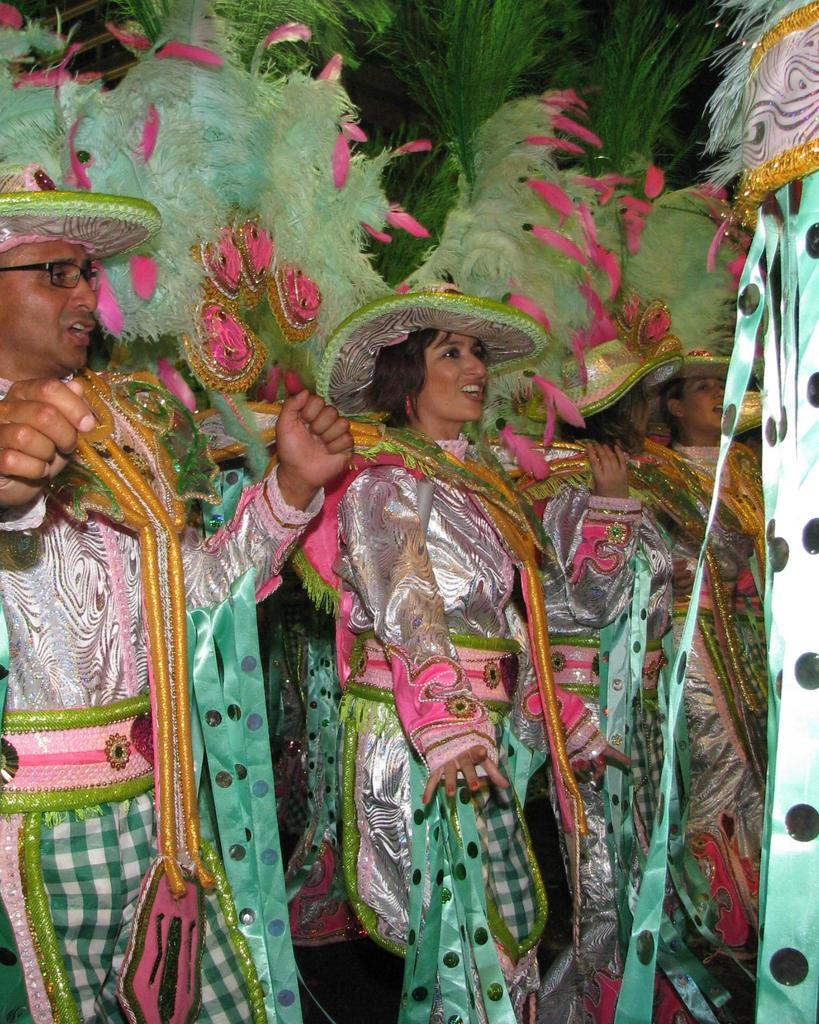Who is present in the image? There are people in the image. What are the people wearing in the image? The people are wearing green color costumes. Can you describe the gender distribution of the people in the image? There are both men and women in the image. What type of system is depicted on the canvas in the image? There is no canvas or system present in the image; it features people wearing green color costumes. 